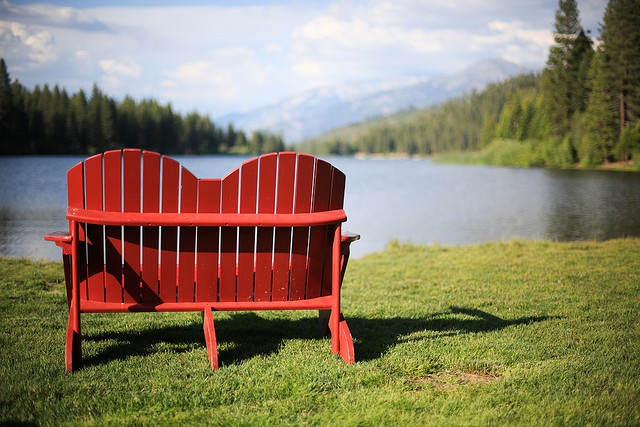Describe the objects in this image and their specific colors. I can see a bench in gray, brown, black, salmon, and maroon tones in this image. 